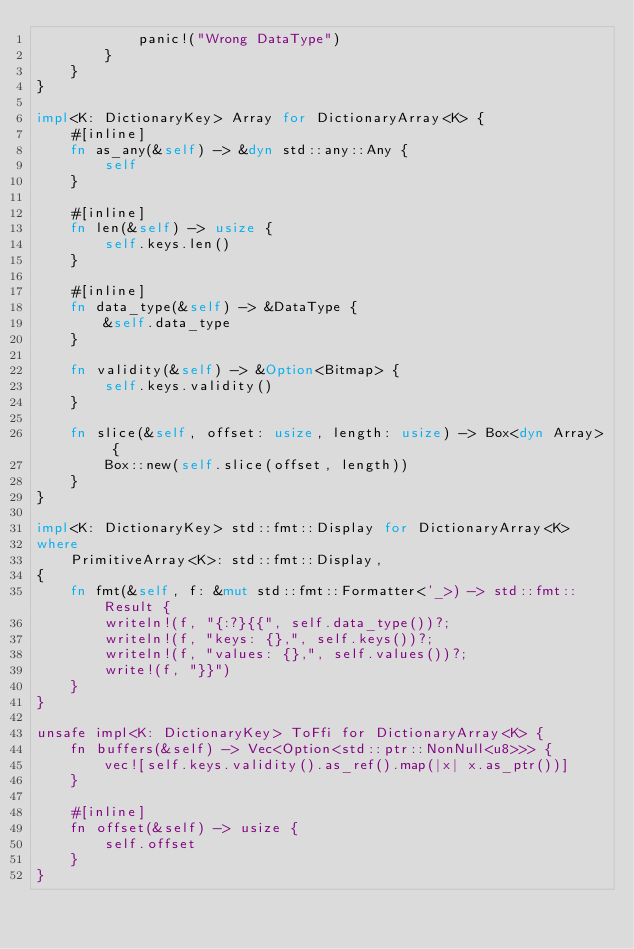Convert code to text. <code><loc_0><loc_0><loc_500><loc_500><_Rust_>            panic!("Wrong DataType")
        }
    }
}

impl<K: DictionaryKey> Array for DictionaryArray<K> {
    #[inline]
    fn as_any(&self) -> &dyn std::any::Any {
        self
    }

    #[inline]
    fn len(&self) -> usize {
        self.keys.len()
    }

    #[inline]
    fn data_type(&self) -> &DataType {
        &self.data_type
    }

    fn validity(&self) -> &Option<Bitmap> {
        self.keys.validity()
    }

    fn slice(&self, offset: usize, length: usize) -> Box<dyn Array> {
        Box::new(self.slice(offset, length))
    }
}

impl<K: DictionaryKey> std::fmt::Display for DictionaryArray<K>
where
    PrimitiveArray<K>: std::fmt::Display,
{
    fn fmt(&self, f: &mut std::fmt::Formatter<'_>) -> std::fmt::Result {
        writeln!(f, "{:?}{{", self.data_type())?;
        writeln!(f, "keys: {},", self.keys())?;
        writeln!(f, "values: {},", self.values())?;
        write!(f, "}}")
    }
}

unsafe impl<K: DictionaryKey> ToFfi for DictionaryArray<K> {
    fn buffers(&self) -> Vec<Option<std::ptr::NonNull<u8>>> {
        vec![self.keys.validity().as_ref().map(|x| x.as_ptr())]
    }

    #[inline]
    fn offset(&self) -> usize {
        self.offset
    }
}
</code> 